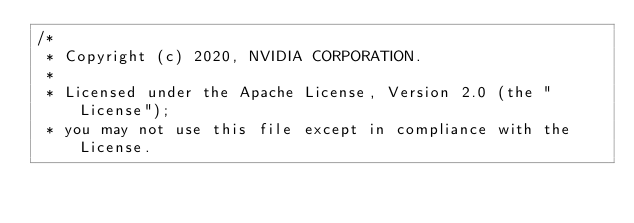<code> <loc_0><loc_0><loc_500><loc_500><_Cuda_>/*
 * Copyright (c) 2020, NVIDIA CORPORATION.
 *
 * Licensed under the Apache License, Version 2.0 (the "License");
 * you may not use this file except in compliance with the License.</code> 